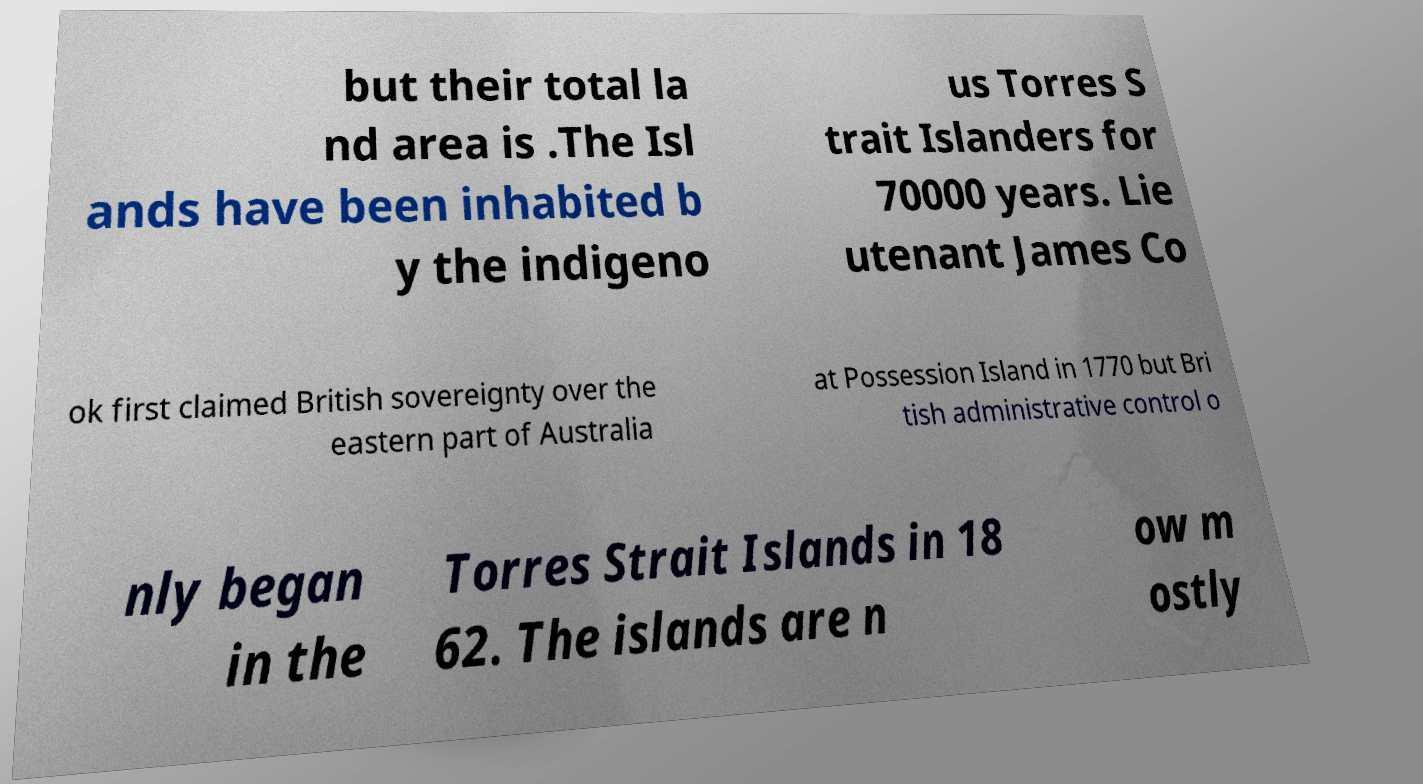Can you read and provide the text displayed in the image?This photo seems to have some interesting text. Can you extract and type it out for me? but their total la nd area is .The Isl ands have been inhabited b y the indigeno us Torres S trait Islanders for 70000 years. Lie utenant James Co ok first claimed British sovereignty over the eastern part of Australia at Possession Island in 1770 but Bri tish administrative control o nly began in the Torres Strait Islands in 18 62. The islands are n ow m ostly 